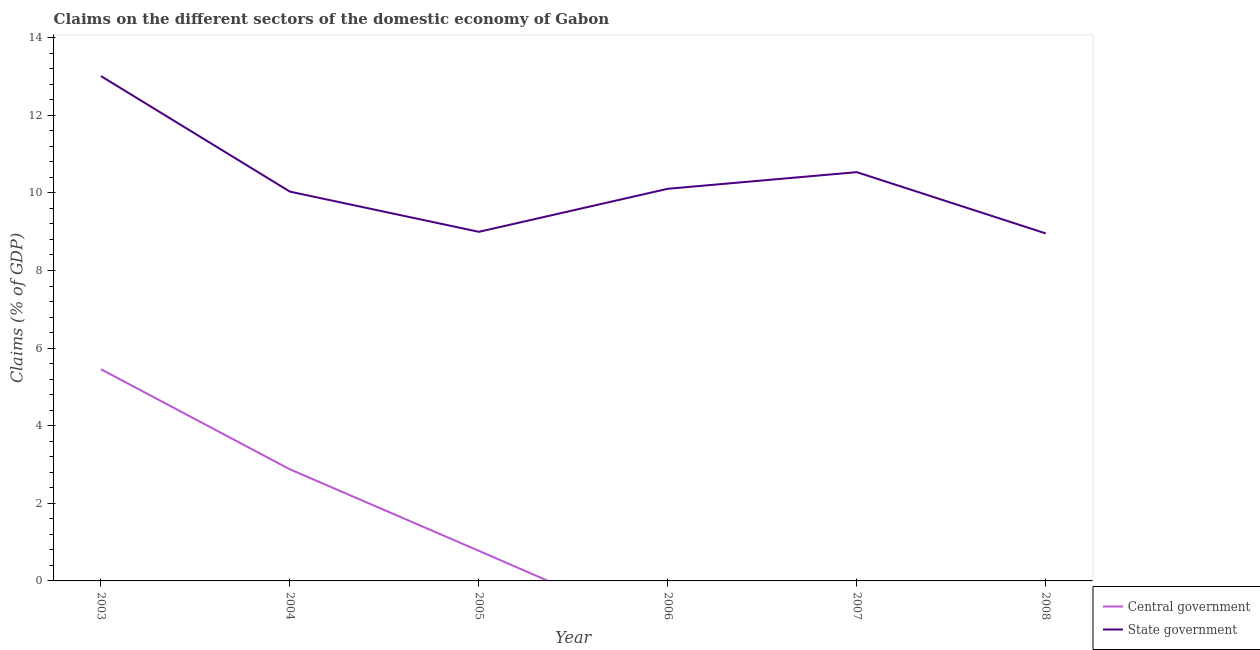How many different coloured lines are there?
Provide a succinct answer. 2. Does the line corresponding to claims on central government intersect with the line corresponding to claims on state government?
Keep it short and to the point. No. What is the claims on state government in 2007?
Your response must be concise. 10.53. Across all years, what is the maximum claims on state government?
Your answer should be very brief. 13.01. Across all years, what is the minimum claims on state government?
Your answer should be very brief. 8.96. What is the total claims on central government in the graph?
Offer a very short reply. 9.11. What is the difference between the claims on central government in 2003 and that in 2004?
Give a very brief answer. 2.58. What is the difference between the claims on state government in 2005 and the claims on central government in 2008?
Make the answer very short. 9. What is the average claims on central government per year?
Your answer should be very brief. 1.52. In the year 2003, what is the difference between the claims on state government and claims on central government?
Ensure brevity in your answer.  7.56. What is the ratio of the claims on state government in 2003 to that in 2004?
Offer a terse response. 1.3. Is the claims on state government in 2003 less than that in 2008?
Your response must be concise. No. What is the difference between the highest and the second highest claims on central government?
Your answer should be very brief. 2.58. What is the difference between the highest and the lowest claims on central government?
Your response must be concise. 5.46. In how many years, is the claims on state government greater than the average claims on state government taken over all years?
Your answer should be very brief. 2. Is the sum of the claims on state government in 2006 and 2008 greater than the maximum claims on central government across all years?
Provide a succinct answer. Yes. Does the claims on central government monotonically increase over the years?
Your answer should be very brief. No. Is the claims on central government strictly greater than the claims on state government over the years?
Ensure brevity in your answer.  No. How many lines are there?
Your answer should be compact. 2. Are the values on the major ticks of Y-axis written in scientific E-notation?
Your response must be concise. No. Where does the legend appear in the graph?
Give a very brief answer. Bottom right. What is the title of the graph?
Offer a terse response. Claims on the different sectors of the domestic economy of Gabon. What is the label or title of the Y-axis?
Provide a short and direct response. Claims (% of GDP). What is the Claims (% of GDP) in Central government in 2003?
Offer a very short reply. 5.46. What is the Claims (% of GDP) in State government in 2003?
Make the answer very short. 13.01. What is the Claims (% of GDP) in Central government in 2004?
Offer a very short reply. 2.88. What is the Claims (% of GDP) of State government in 2004?
Give a very brief answer. 10.03. What is the Claims (% of GDP) in Central government in 2005?
Provide a succinct answer. 0.78. What is the Claims (% of GDP) of State government in 2005?
Provide a short and direct response. 9. What is the Claims (% of GDP) of Central government in 2006?
Provide a succinct answer. 0. What is the Claims (% of GDP) of State government in 2006?
Offer a terse response. 10.11. What is the Claims (% of GDP) of Central government in 2007?
Ensure brevity in your answer.  0. What is the Claims (% of GDP) in State government in 2007?
Offer a terse response. 10.53. What is the Claims (% of GDP) of State government in 2008?
Offer a very short reply. 8.96. Across all years, what is the maximum Claims (% of GDP) in Central government?
Provide a succinct answer. 5.46. Across all years, what is the maximum Claims (% of GDP) in State government?
Your answer should be compact. 13.01. Across all years, what is the minimum Claims (% of GDP) of State government?
Make the answer very short. 8.96. What is the total Claims (% of GDP) of Central government in the graph?
Your answer should be very brief. 9.11. What is the total Claims (% of GDP) of State government in the graph?
Your response must be concise. 61.64. What is the difference between the Claims (% of GDP) of Central government in 2003 and that in 2004?
Offer a terse response. 2.58. What is the difference between the Claims (% of GDP) in State government in 2003 and that in 2004?
Ensure brevity in your answer.  2.98. What is the difference between the Claims (% of GDP) of Central government in 2003 and that in 2005?
Give a very brief answer. 4.68. What is the difference between the Claims (% of GDP) in State government in 2003 and that in 2005?
Your answer should be compact. 4.01. What is the difference between the Claims (% of GDP) in State government in 2003 and that in 2006?
Make the answer very short. 2.9. What is the difference between the Claims (% of GDP) in State government in 2003 and that in 2007?
Offer a terse response. 2.48. What is the difference between the Claims (% of GDP) of State government in 2003 and that in 2008?
Ensure brevity in your answer.  4.05. What is the difference between the Claims (% of GDP) in Central government in 2004 and that in 2005?
Keep it short and to the point. 2.1. What is the difference between the Claims (% of GDP) of State government in 2004 and that in 2005?
Give a very brief answer. 1.04. What is the difference between the Claims (% of GDP) in State government in 2004 and that in 2006?
Provide a succinct answer. -0.07. What is the difference between the Claims (% of GDP) of State government in 2004 and that in 2007?
Offer a terse response. -0.5. What is the difference between the Claims (% of GDP) of State government in 2004 and that in 2008?
Make the answer very short. 1.08. What is the difference between the Claims (% of GDP) in State government in 2005 and that in 2006?
Give a very brief answer. -1.11. What is the difference between the Claims (% of GDP) in State government in 2005 and that in 2007?
Ensure brevity in your answer.  -1.54. What is the difference between the Claims (% of GDP) in State government in 2005 and that in 2008?
Offer a terse response. 0.04. What is the difference between the Claims (% of GDP) in State government in 2006 and that in 2007?
Offer a very short reply. -0.43. What is the difference between the Claims (% of GDP) in State government in 2006 and that in 2008?
Your answer should be compact. 1.15. What is the difference between the Claims (% of GDP) of State government in 2007 and that in 2008?
Your answer should be compact. 1.58. What is the difference between the Claims (% of GDP) in Central government in 2003 and the Claims (% of GDP) in State government in 2004?
Keep it short and to the point. -4.58. What is the difference between the Claims (% of GDP) of Central government in 2003 and the Claims (% of GDP) of State government in 2005?
Your answer should be very brief. -3.54. What is the difference between the Claims (% of GDP) in Central government in 2003 and the Claims (% of GDP) in State government in 2006?
Your response must be concise. -4.65. What is the difference between the Claims (% of GDP) in Central government in 2003 and the Claims (% of GDP) in State government in 2007?
Ensure brevity in your answer.  -5.08. What is the difference between the Claims (% of GDP) in Central government in 2003 and the Claims (% of GDP) in State government in 2008?
Keep it short and to the point. -3.5. What is the difference between the Claims (% of GDP) in Central government in 2004 and the Claims (% of GDP) in State government in 2005?
Give a very brief answer. -6.12. What is the difference between the Claims (% of GDP) in Central government in 2004 and the Claims (% of GDP) in State government in 2006?
Provide a succinct answer. -7.23. What is the difference between the Claims (% of GDP) in Central government in 2004 and the Claims (% of GDP) in State government in 2007?
Your answer should be very brief. -7.66. What is the difference between the Claims (% of GDP) in Central government in 2004 and the Claims (% of GDP) in State government in 2008?
Offer a very short reply. -6.08. What is the difference between the Claims (% of GDP) in Central government in 2005 and the Claims (% of GDP) in State government in 2006?
Provide a succinct answer. -9.33. What is the difference between the Claims (% of GDP) in Central government in 2005 and the Claims (% of GDP) in State government in 2007?
Ensure brevity in your answer.  -9.76. What is the difference between the Claims (% of GDP) in Central government in 2005 and the Claims (% of GDP) in State government in 2008?
Make the answer very short. -8.18. What is the average Claims (% of GDP) of Central government per year?
Provide a succinct answer. 1.52. What is the average Claims (% of GDP) of State government per year?
Offer a very short reply. 10.27. In the year 2003, what is the difference between the Claims (% of GDP) in Central government and Claims (% of GDP) in State government?
Give a very brief answer. -7.56. In the year 2004, what is the difference between the Claims (% of GDP) in Central government and Claims (% of GDP) in State government?
Ensure brevity in your answer.  -7.16. In the year 2005, what is the difference between the Claims (% of GDP) in Central government and Claims (% of GDP) in State government?
Ensure brevity in your answer.  -8.22. What is the ratio of the Claims (% of GDP) in Central government in 2003 to that in 2004?
Make the answer very short. 1.9. What is the ratio of the Claims (% of GDP) in State government in 2003 to that in 2004?
Provide a succinct answer. 1.3. What is the ratio of the Claims (% of GDP) in Central government in 2003 to that in 2005?
Provide a short and direct response. 7.03. What is the ratio of the Claims (% of GDP) of State government in 2003 to that in 2005?
Offer a very short reply. 1.45. What is the ratio of the Claims (% of GDP) in State government in 2003 to that in 2006?
Ensure brevity in your answer.  1.29. What is the ratio of the Claims (% of GDP) in State government in 2003 to that in 2007?
Keep it short and to the point. 1.24. What is the ratio of the Claims (% of GDP) in State government in 2003 to that in 2008?
Ensure brevity in your answer.  1.45. What is the ratio of the Claims (% of GDP) of Central government in 2004 to that in 2005?
Make the answer very short. 3.71. What is the ratio of the Claims (% of GDP) in State government in 2004 to that in 2005?
Provide a succinct answer. 1.12. What is the ratio of the Claims (% of GDP) in State government in 2004 to that in 2007?
Keep it short and to the point. 0.95. What is the ratio of the Claims (% of GDP) in State government in 2004 to that in 2008?
Give a very brief answer. 1.12. What is the ratio of the Claims (% of GDP) in State government in 2005 to that in 2006?
Make the answer very short. 0.89. What is the ratio of the Claims (% of GDP) in State government in 2005 to that in 2007?
Give a very brief answer. 0.85. What is the ratio of the Claims (% of GDP) of State government in 2006 to that in 2007?
Your answer should be compact. 0.96. What is the ratio of the Claims (% of GDP) in State government in 2006 to that in 2008?
Ensure brevity in your answer.  1.13. What is the ratio of the Claims (% of GDP) of State government in 2007 to that in 2008?
Your answer should be very brief. 1.18. What is the difference between the highest and the second highest Claims (% of GDP) of Central government?
Keep it short and to the point. 2.58. What is the difference between the highest and the second highest Claims (% of GDP) of State government?
Keep it short and to the point. 2.48. What is the difference between the highest and the lowest Claims (% of GDP) in Central government?
Offer a very short reply. 5.46. What is the difference between the highest and the lowest Claims (% of GDP) of State government?
Give a very brief answer. 4.05. 